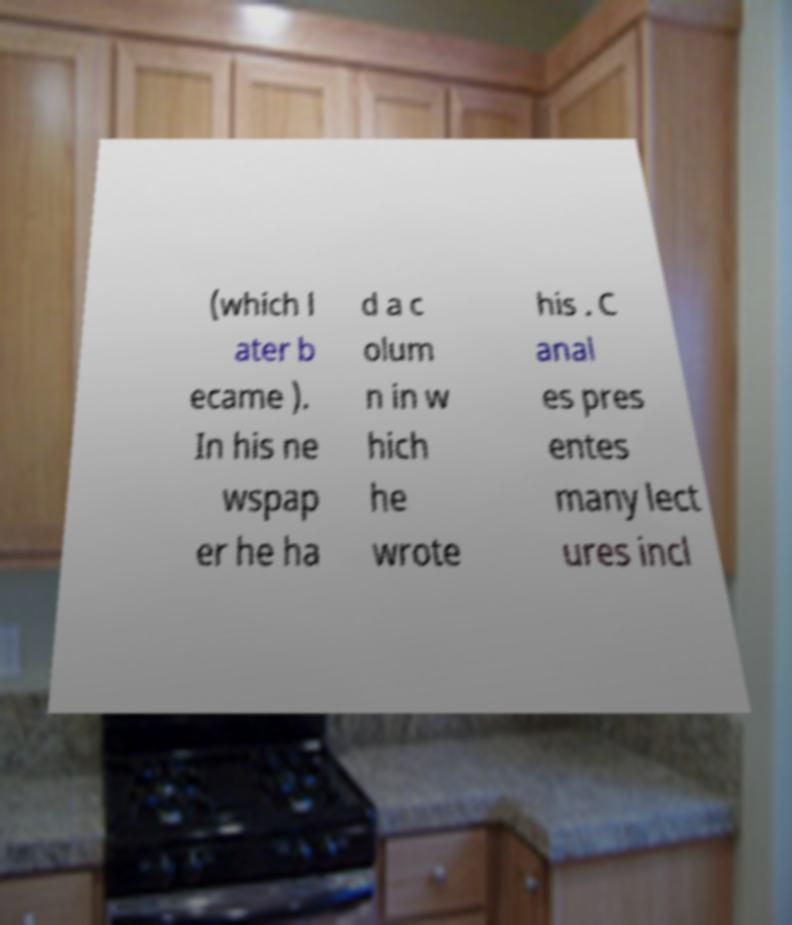Please identify and transcribe the text found in this image. (which l ater b ecame ). In his ne wspap er he ha d a c olum n in w hich he wrote his . C anal es pres entes many lect ures incl 